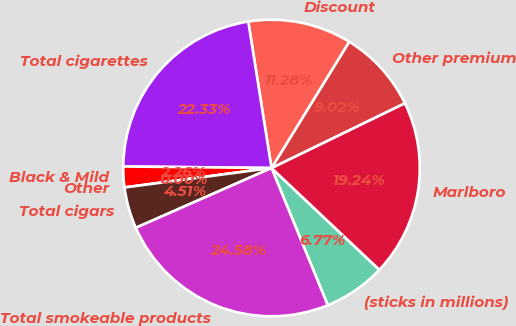<chart> <loc_0><loc_0><loc_500><loc_500><pie_chart><fcel>(sticks in millions)<fcel>Marlboro<fcel>Other premium<fcel>Discount<fcel>Total cigarettes<fcel>Black & Mild<fcel>Other<fcel>Total cigars<fcel>Total smokeable products<nl><fcel>6.77%<fcel>19.24%<fcel>9.02%<fcel>11.28%<fcel>22.33%<fcel>2.26%<fcel>0.0%<fcel>4.51%<fcel>24.58%<nl></chart> 